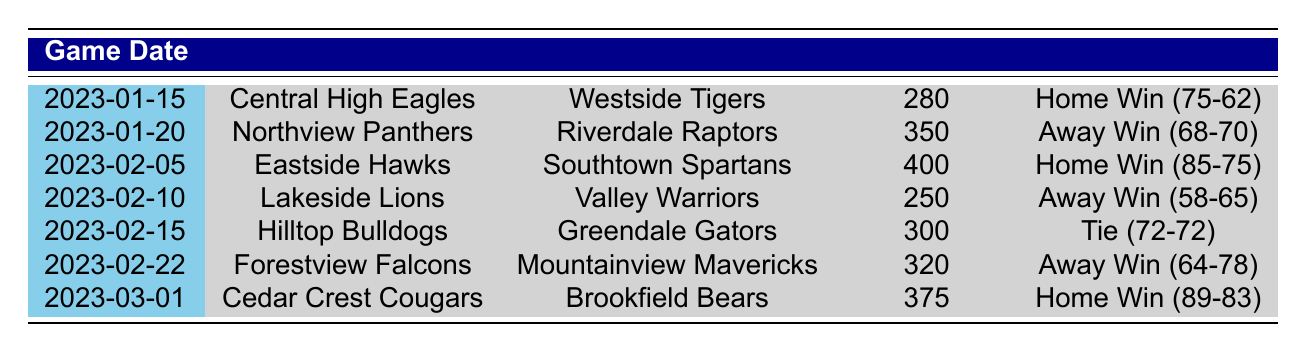What is the attendance for the game between Cedar Crest Cougars and Brookfield Bears? The attendance for that game is found in the table under the corresponding row for the game dated 2023-03-01, which states the attendance as 375.
Answer: 375 Which game had the highest attendance? To find the highest attendance, we compare attendance values from all games listed in the table. The game on 2023-02-05 had the highest attendance of 400.
Answer: 400 How many games resulted in a home win? By reviewing the result column in the table, we count the number of games that state "Home Win." There are four games where the home team won (2023-01-15, 2023-02-05, and 2023-03-01).
Answer: 4 What was the average attendance for all games played? To calculate the average attendance, we sum the attendance figures: 280 + 350 + 400 + 250 + 300 + 320 + 375 = 2275. Next, we divide this sum by the number of games played, which is 7, yielding an average of 2275 / 7 = approximately 324.
Answer: 324 Did any games end in a tie? Looking through the result column in the table, there is one instance where the result is "Tie," which is between Hilltop Bulldogs and Greendale Gators on 2023-02-15.
Answer: Yes Which home team had the lowest score in a winning game? We need to look at the home win games, which are 2023-01-15, 2023-02-05, and 2023-03-01. Among these, the home team scores are 75, 85, and 89 respectively. The lowest score among these winning home games is 75 points (Central High Eagles).
Answer: 75 What is the difference in score between the highest-scoring home game and the highest-scoring away game? The highest-scoring home game was on 2023-03-01 where the home team scored 89 points. The highest-scoring away game was on 2023-01-20 where the away team scored 70 points. The difference is 89 - 70 = 19 points.
Answer: 19 How many games had an attendance of over 300? We can see from the attendance values for each game, the games with attendance values over 300 are 2023-01-20 (350), 2023-02-05 (400), 2023-02-15 (300), and 2023-03-01 (375). Thus, there are four games with attendance over 300.
Answer: 4 